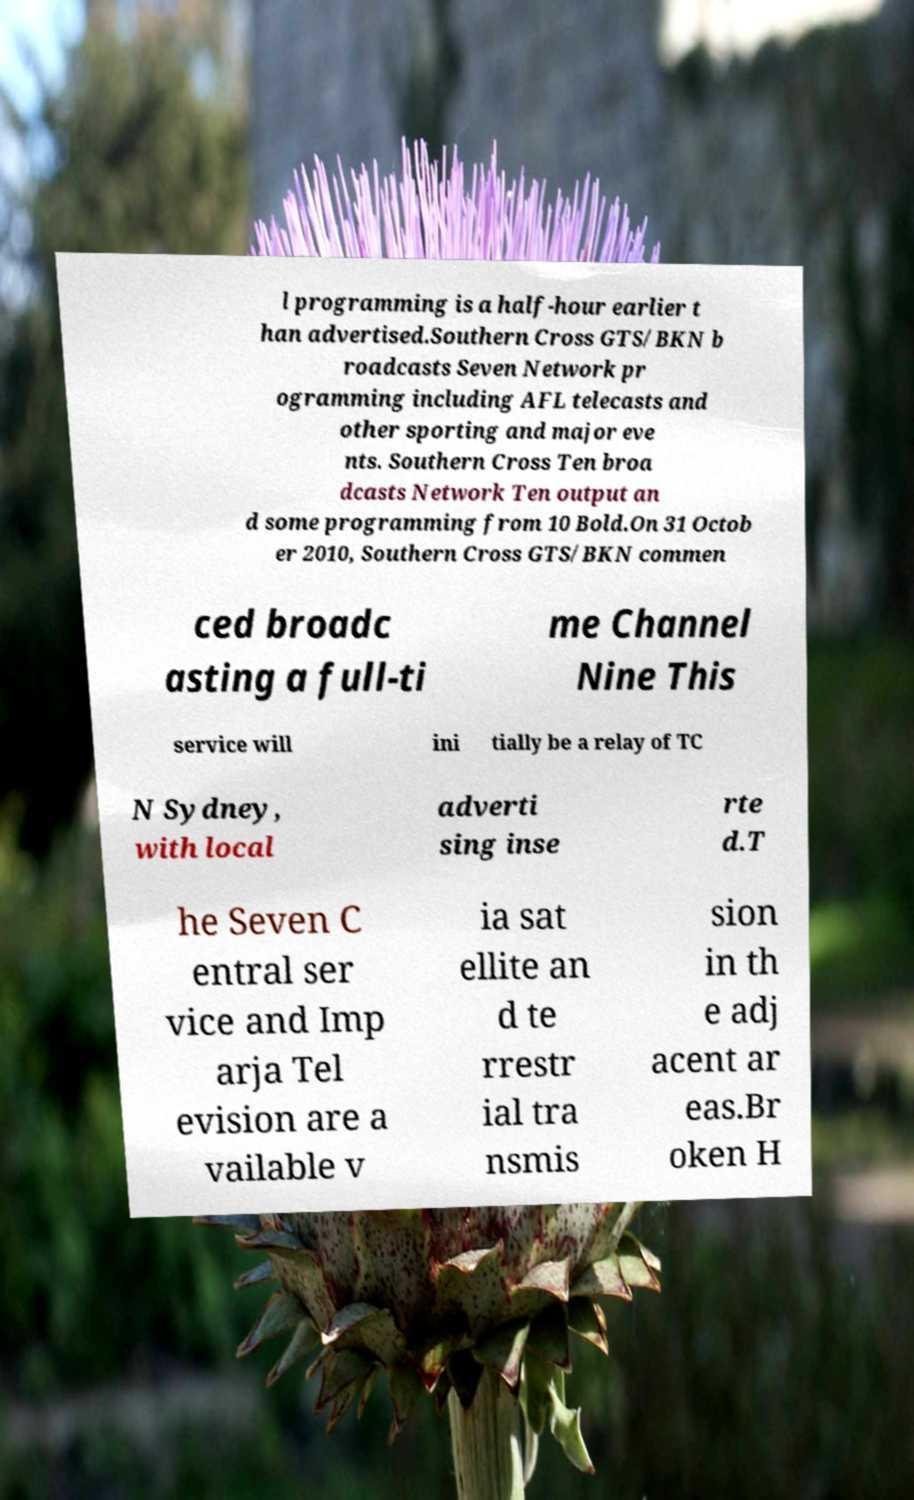Please read and relay the text visible in this image. What does it say? l programming is a half-hour earlier t han advertised.Southern Cross GTS/BKN b roadcasts Seven Network pr ogramming including AFL telecasts and other sporting and major eve nts. Southern Cross Ten broa dcasts Network Ten output an d some programming from 10 Bold.On 31 Octob er 2010, Southern Cross GTS/BKN commen ced broadc asting a full-ti me Channel Nine This service will ini tially be a relay of TC N Sydney, with local adverti sing inse rte d.T he Seven C entral ser vice and Imp arja Tel evision are a vailable v ia sat ellite an d te rrestr ial tra nsmis sion in th e adj acent ar eas.Br oken H 